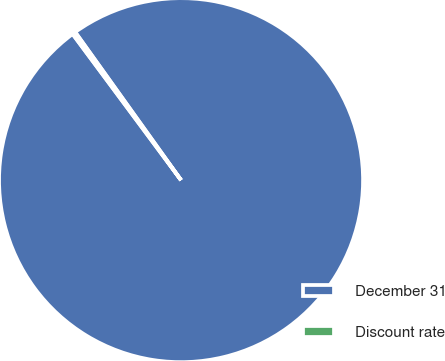<chart> <loc_0><loc_0><loc_500><loc_500><pie_chart><fcel>December 31<fcel>Discount rate<nl><fcel>99.72%<fcel>0.28%<nl></chart> 